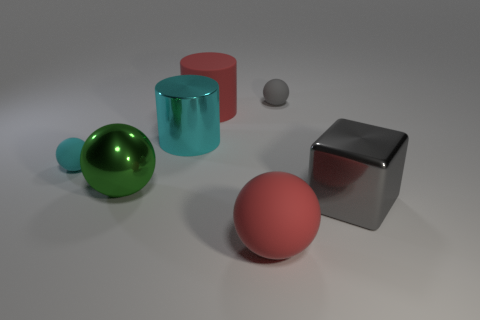Subtract all gray balls. How many balls are left? 3 Subtract 1 blocks. How many blocks are left? 0 Subtract all green balls. How many balls are left? 3 Add 1 gray cubes. How many objects exist? 8 Subtract all gray cylinders. Subtract all cyan balls. How many cylinders are left? 2 Add 7 big cyan metal things. How many big cyan metal things are left? 8 Add 4 gray things. How many gray things exist? 6 Subtract 0 purple cylinders. How many objects are left? 7 Subtract all cylinders. How many objects are left? 5 Subtract all yellow cylinders. How many brown blocks are left? 0 